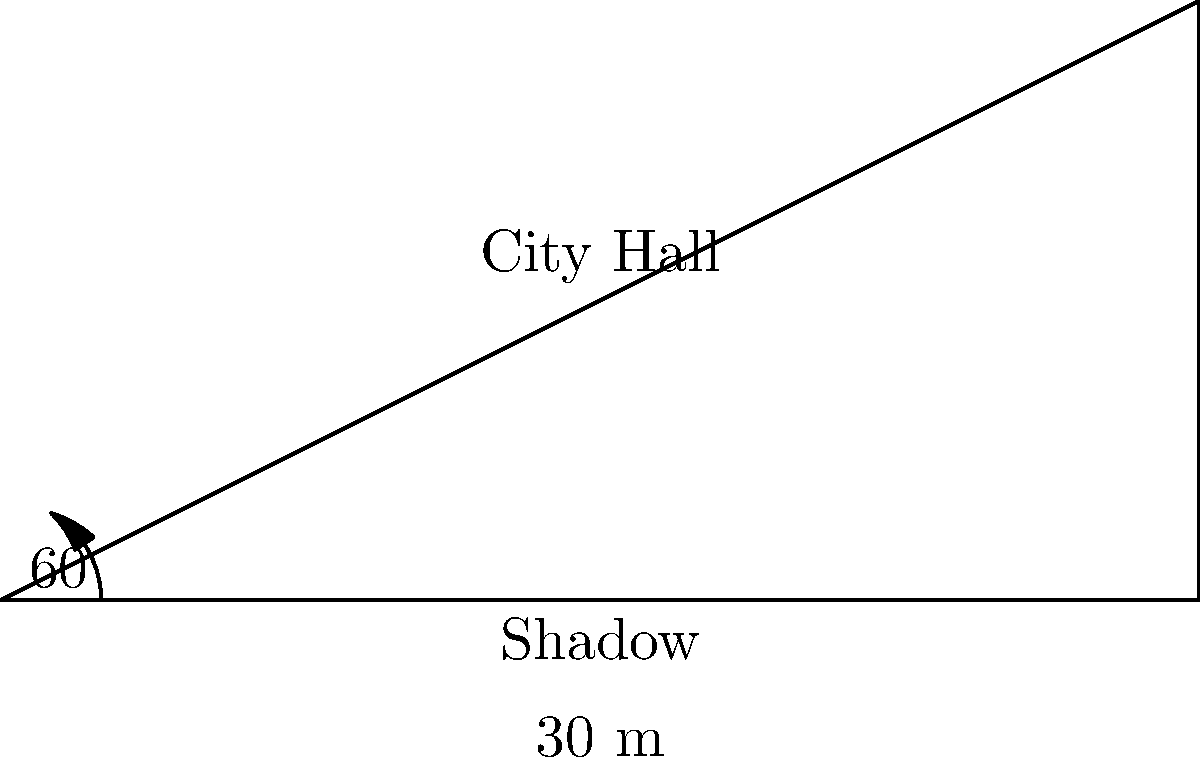A historian is studying the architecture of a historic city hall. To determine its height, they measure its shadow to be 30 meters long when the angle of elevation of the sun is 60°. Using this information, calculate the height of the city hall to the nearest meter. To solve this problem, we can use trigonometry, specifically the tangent function. Let's approach this step-by-step:

1) In a right triangle, tangent of an angle is the ratio of the opposite side to the adjacent side.

2) In this case:
   - The angle of elevation is 60°
   - The adjacent side (shadow length) is 30 meters
   - The opposite side (height of the city hall) is what we're trying to find

3) Let's call the height of the city hall $h$. We can write the equation:

   $\tan(60°) = \frac{h}{30}$

4) We know that $\tan(60°) = \sqrt{3}$, so we can rewrite the equation:

   $\sqrt{3} = \frac{h}{30}$

5) To solve for $h$, multiply both sides by 30:

   $30\sqrt{3} = h$

6) Calculate the value:
   $30\sqrt{3} \approx 51.96$ meters

7) Rounding to the nearest meter:

   $h \approx 52$ meters

Therefore, the height of the historic city hall is approximately 52 meters.
Answer: 52 meters 